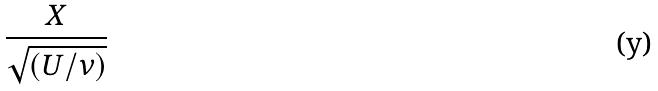<formula> <loc_0><loc_0><loc_500><loc_500>\frac { X } { \sqrt { ( U / \nu ) } }</formula> 